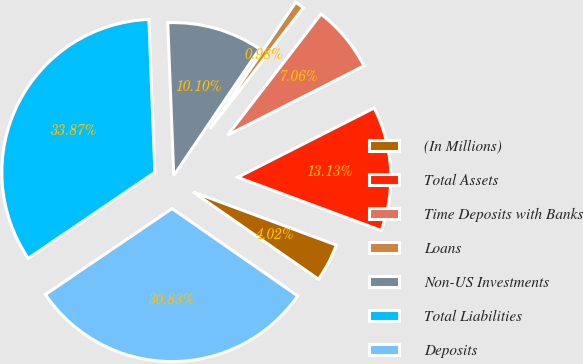Convert chart to OTSL. <chart><loc_0><loc_0><loc_500><loc_500><pie_chart><fcel>(In Millions)<fcel>Total Assets<fcel>Time Deposits with Banks<fcel>Loans<fcel>Non-US Investments<fcel>Total Liabilities<fcel>Deposits<nl><fcel>4.02%<fcel>13.13%<fcel>7.06%<fcel>0.98%<fcel>10.1%<fcel>33.87%<fcel>30.83%<nl></chart> 